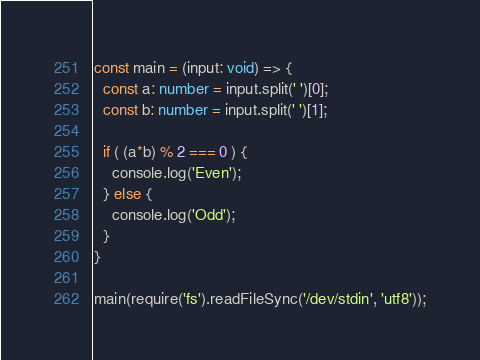<code> <loc_0><loc_0><loc_500><loc_500><_TypeScript_>const main = (input: void) => {
  const a: number = input.split(' ')[0];
  const b: number = input.split(' ')[1];

  if ( (a*b) % 2 === 0 ) {
    console.log('Even');
  } else {
    console.log('Odd');
  }
}

main(require('fs').readFileSync('/dev/stdin', 'utf8'));</code> 